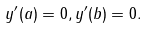<formula> <loc_0><loc_0><loc_500><loc_500>y ^ { \prime } ( a ) = 0 , y ^ { \prime } ( b ) = 0 .</formula> 